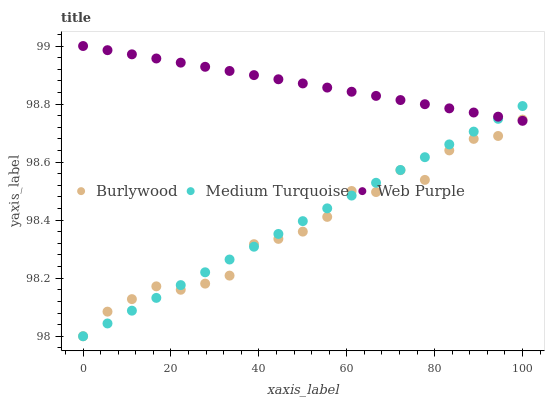Does Burlywood have the minimum area under the curve?
Answer yes or no. Yes. Does Web Purple have the maximum area under the curve?
Answer yes or no. Yes. Does Medium Turquoise have the minimum area under the curve?
Answer yes or no. No. Does Medium Turquoise have the maximum area under the curve?
Answer yes or no. No. Is Web Purple the smoothest?
Answer yes or no. Yes. Is Burlywood the roughest?
Answer yes or no. Yes. Is Medium Turquoise the smoothest?
Answer yes or no. No. Is Medium Turquoise the roughest?
Answer yes or no. No. Does Burlywood have the lowest value?
Answer yes or no. Yes. Does Web Purple have the lowest value?
Answer yes or no. No. Does Web Purple have the highest value?
Answer yes or no. Yes. Does Medium Turquoise have the highest value?
Answer yes or no. No. Does Burlywood intersect Medium Turquoise?
Answer yes or no. Yes. Is Burlywood less than Medium Turquoise?
Answer yes or no. No. Is Burlywood greater than Medium Turquoise?
Answer yes or no. No. 